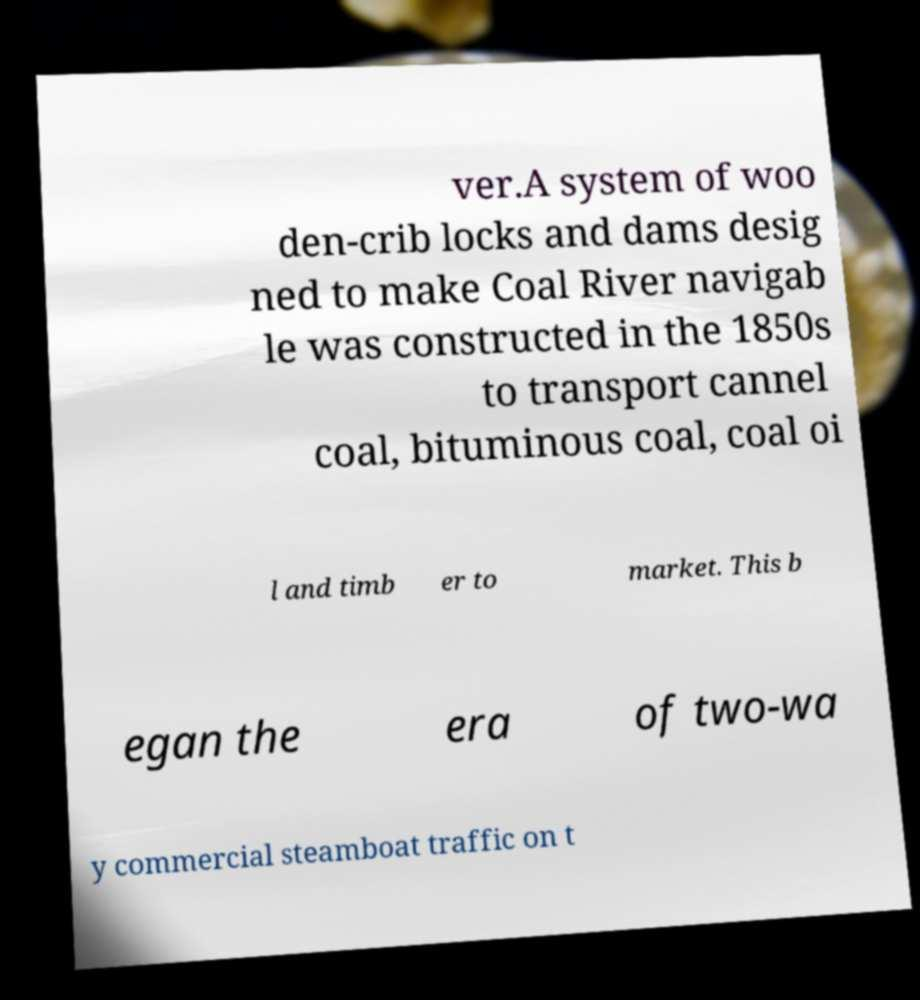Can you read and provide the text displayed in the image?This photo seems to have some interesting text. Can you extract and type it out for me? ver.A system of woo den-crib locks and dams desig ned to make Coal River navigab le was constructed in the 1850s to transport cannel coal, bituminous coal, coal oi l and timb er to market. This b egan the era of two-wa y commercial steamboat traffic on t 